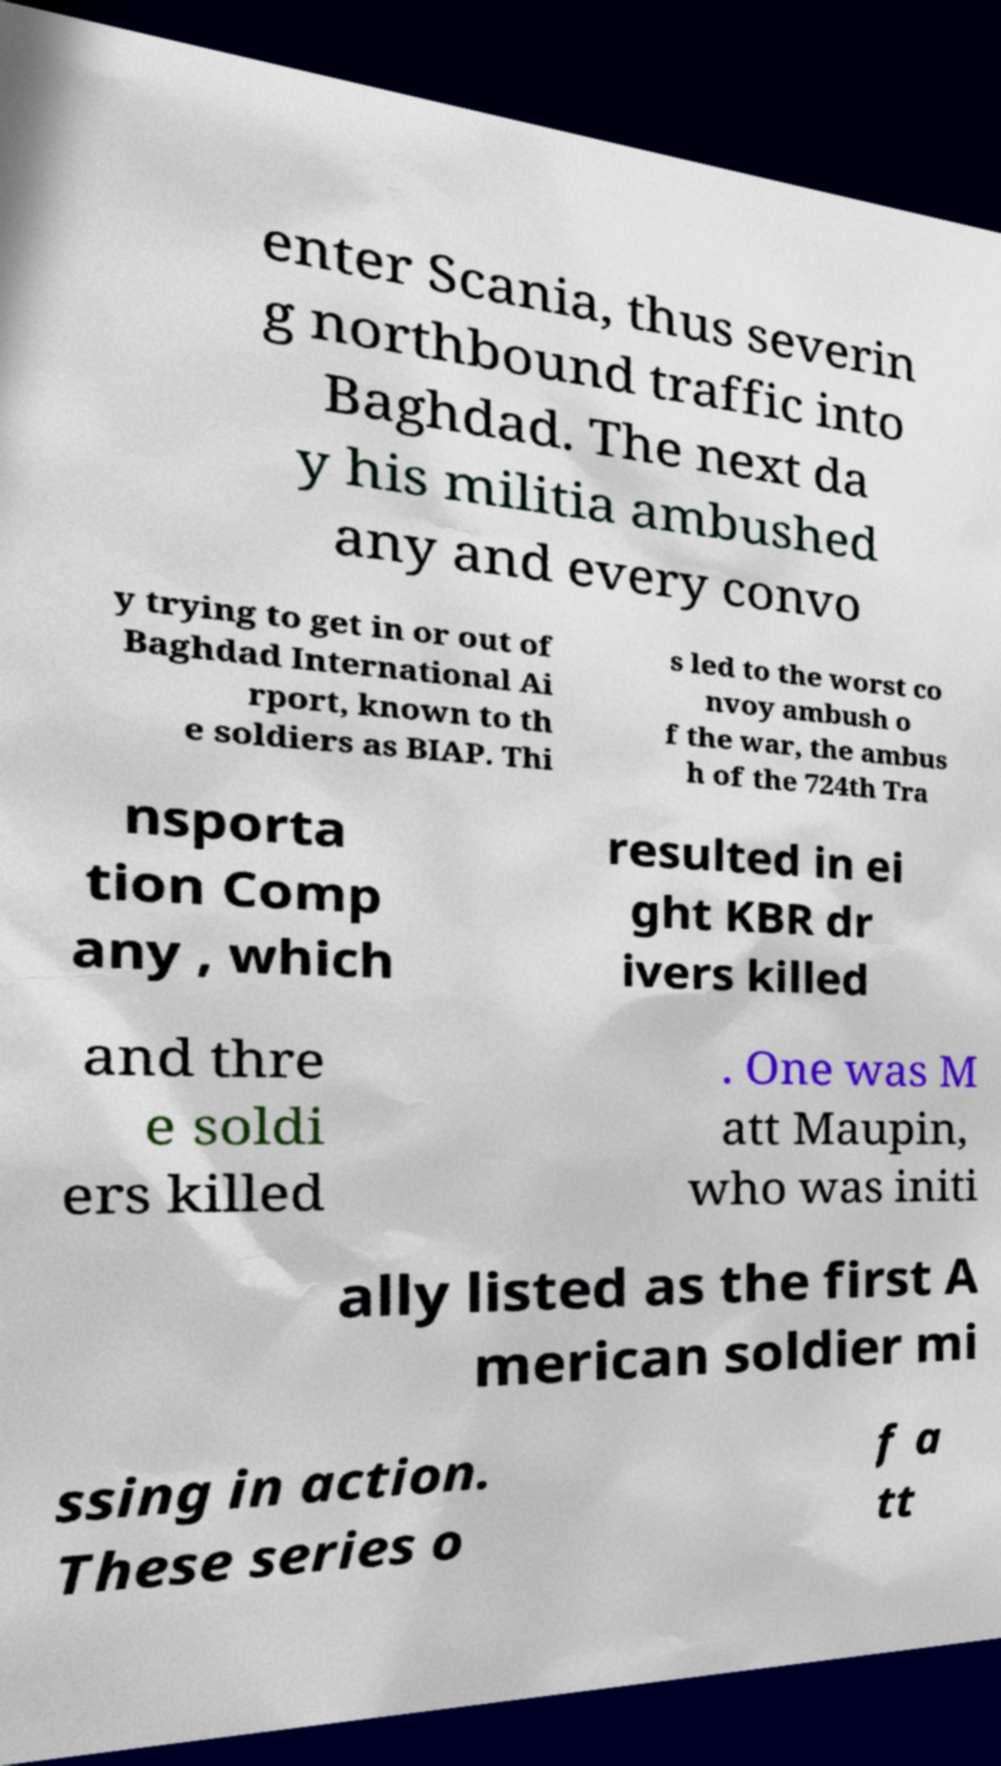Please read and relay the text visible in this image. What does it say? enter Scania, thus severin g northbound traffic into Baghdad. The next da y his militia ambushed any and every convo y trying to get in or out of Baghdad International Ai rport, known to th e soldiers as BIAP. Thi s led to the worst co nvoy ambush o f the war, the ambus h of the 724th Tra nsporta tion Comp any , which resulted in ei ght KBR dr ivers killed and thre e soldi ers killed . One was M att Maupin, who was initi ally listed as the first A merican soldier mi ssing in action. These series o f a tt 